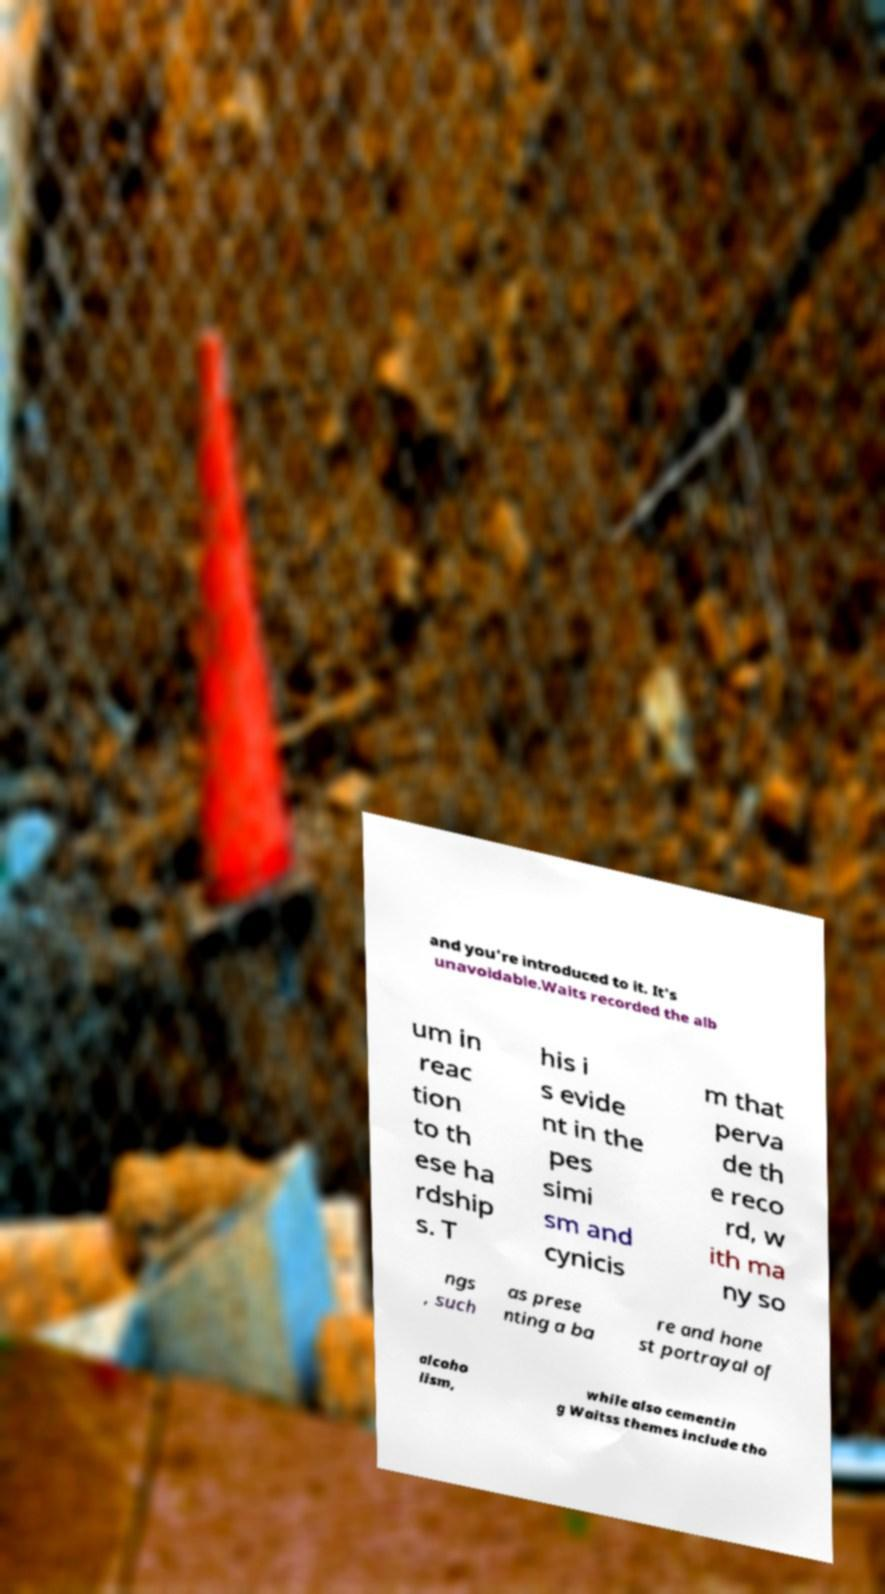What messages or text are displayed in this image? I need them in a readable, typed format. and you're introduced to it. It's unavoidable.Waits recorded the alb um in reac tion to th ese ha rdship s. T his i s evide nt in the pes simi sm and cynicis m that perva de th e reco rd, w ith ma ny so ngs , such as prese nting a ba re and hone st portrayal of alcoho lism, while also cementin g Waitss themes include tho 